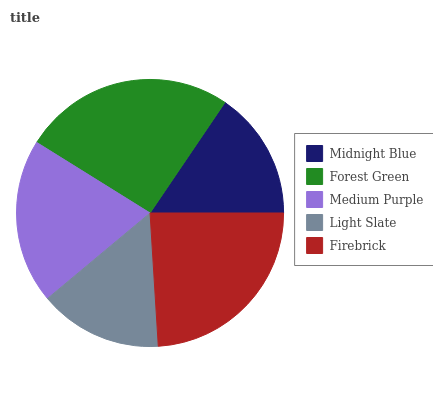Is Light Slate the minimum?
Answer yes or no. Yes. Is Forest Green the maximum?
Answer yes or no. Yes. Is Medium Purple the minimum?
Answer yes or no. No. Is Medium Purple the maximum?
Answer yes or no. No. Is Forest Green greater than Medium Purple?
Answer yes or no. Yes. Is Medium Purple less than Forest Green?
Answer yes or no. Yes. Is Medium Purple greater than Forest Green?
Answer yes or no. No. Is Forest Green less than Medium Purple?
Answer yes or no. No. Is Medium Purple the high median?
Answer yes or no. Yes. Is Medium Purple the low median?
Answer yes or no. Yes. Is Firebrick the high median?
Answer yes or no. No. Is Light Slate the low median?
Answer yes or no. No. 